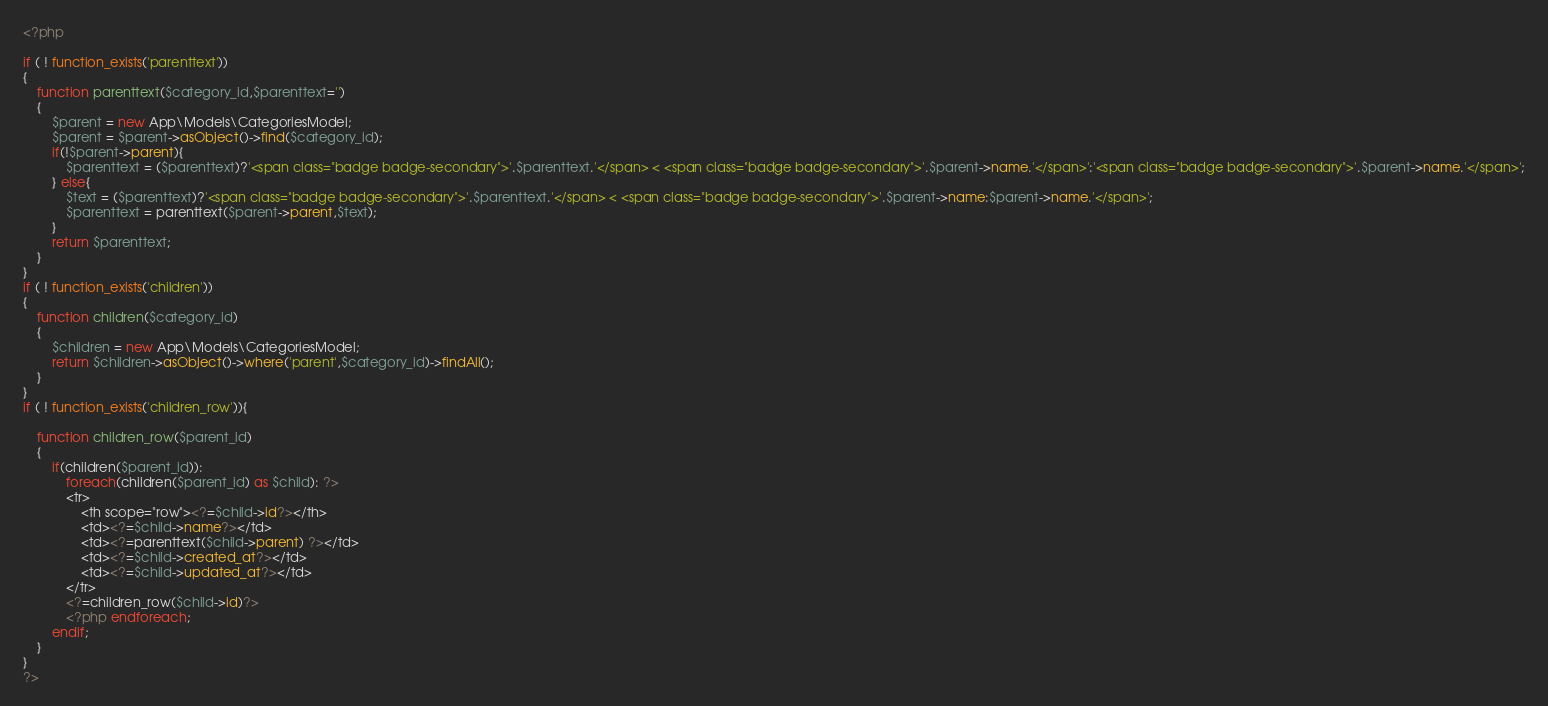<code> <loc_0><loc_0><loc_500><loc_500><_PHP_><?php 

if ( ! function_exists('parenttext'))
{
    function parenttext($category_id,$parenttext='')
    {
        $parent = new App\Models\CategoriesModel;
        $parent = $parent->asObject()->find($category_id);
        if(!$parent->parent){
            $parenttext = ($parenttext)?'<span class="badge badge-secondary">'.$parenttext.'</span> < <span class="badge badge-secondary">'.$parent->name.'</span>':'<span class="badge badge-secondary">'.$parent->name.'</span>';
        } else{
            $text = ($parenttext)?'<span class="badge badge-secondary">'.$parenttext.'</span> < <span class="badge badge-secondary">'.$parent->name:$parent->name.'</span>';
            $parenttext = parenttext($parent->parent,$text);
        }
        return $parenttext;
    }
}
if ( ! function_exists('children'))
{
    function children($category_id)
    {
        $children = new App\Models\CategoriesModel;
        return $children->asObject()->where('parent',$category_id)->findAll();
    }
}
if ( ! function_exists('children_row')){

    function children_row($parent_id)
    {
        if(children($parent_id)): 
            foreach(children($parent_id) as $child): ?>
            <tr>
                <th scope="row"><?=$child->id?></th>
                <td><?=$child->name?></td>
                <td><?=parenttext($child->parent) ?></td>
                <td><?=$child->created_at?></td>
                <td><?=$child->updated_at?></td>
            </tr>
            <?=children_row($child->id)?>
            <?php endforeach; 
        endif; 
    }
}
?></code> 